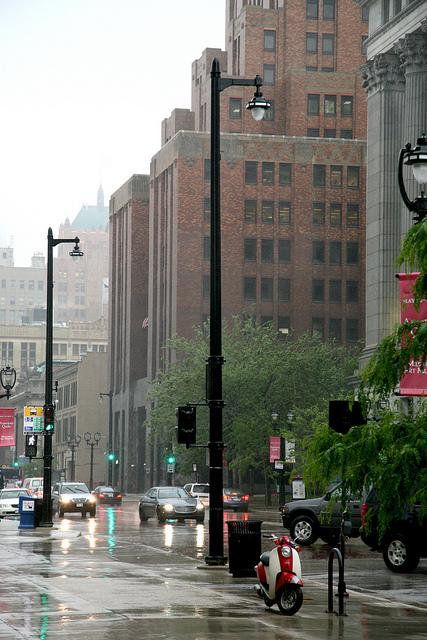What has caused the roads to look reflective? rain 